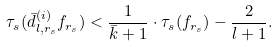Convert formula to latex. <formula><loc_0><loc_0><loc_500><loc_500>\tau _ { s } ( \bar { d } ^ { ( i ) } _ { l , r _ { s } } f _ { r _ { s } } ) < \frac { 1 } { \bar { k } + 1 } \cdot \tau _ { s } ( f _ { r _ { s } } ) - \frac { 2 } { l + 1 } .</formula> 